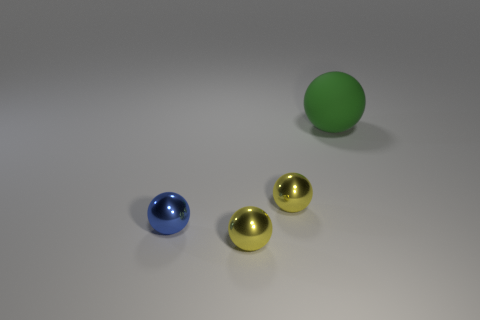Add 1 rubber spheres. How many objects exist? 5 Subtract all large gray shiny cylinders. Subtract all yellow things. How many objects are left? 2 Add 3 blue shiny things. How many blue shiny things are left? 4 Add 3 tiny metallic objects. How many tiny metallic objects exist? 6 Subtract 2 yellow spheres. How many objects are left? 2 